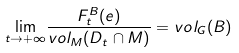<formula> <loc_0><loc_0><loc_500><loc_500>\underset { t \rightarrow + \infty } { \lim } \frac { F _ { t } ^ { B } ( e ) } { v o l _ { M } ( D _ { t } \cap M ) } = v o l _ { G } ( B )</formula> 